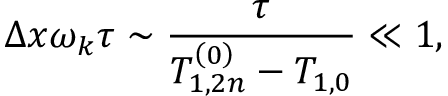Convert formula to latex. <formula><loc_0><loc_0><loc_500><loc_500>\Delta x \omega _ { k } \tau \sim \frac { \tau } { T _ { 1 , 2 n } ^ { \left ( 0 \right ) } - T _ { 1 , 0 } } \ll 1 ,</formula> 